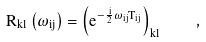Convert formula to latex. <formula><loc_0><loc_0><loc_500><loc_500>R _ { k l } \left ( \omega _ { i j } \right ) = \left ( e ^ { - \frac { i } { 2 } \omega _ { i j } T _ { i j } } \right ) _ { k l } \quad ,</formula> 